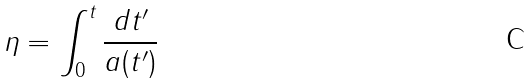<formula> <loc_0><loc_0><loc_500><loc_500>\eta = \int _ { 0 } ^ { t } \frac { d t ^ { \prime } } { a ( t ^ { \prime } ) }</formula> 